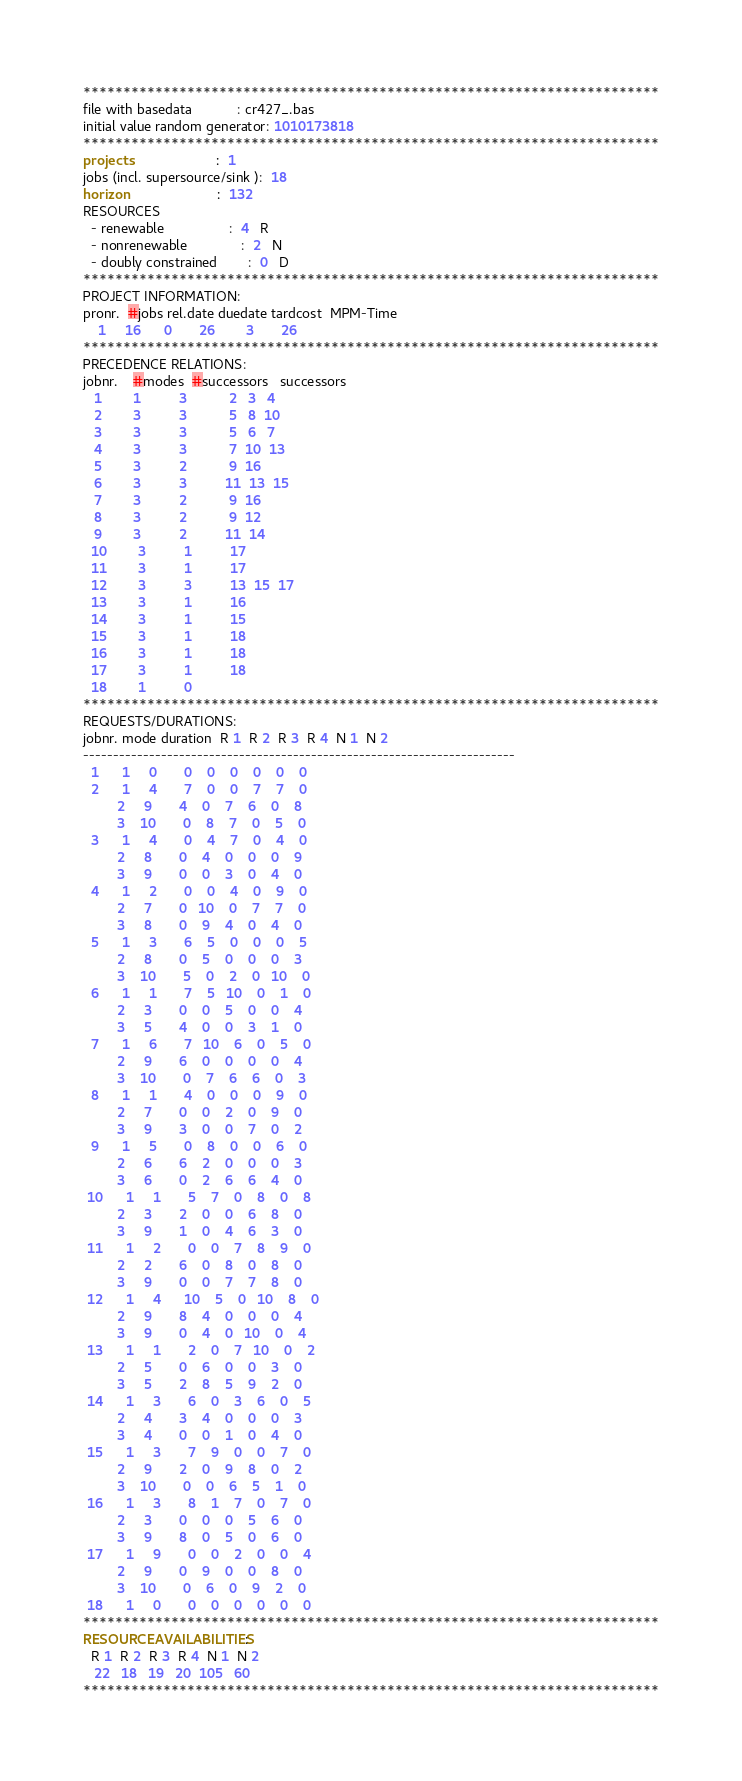<code> <loc_0><loc_0><loc_500><loc_500><_ObjectiveC_>************************************************************************
file with basedata            : cr427_.bas
initial value random generator: 1010173818
************************************************************************
projects                      :  1
jobs (incl. supersource/sink ):  18
horizon                       :  132
RESOURCES
  - renewable                 :  4   R
  - nonrenewable              :  2   N
  - doubly constrained        :  0   D
************************************************************************
PROJECT INFORMATION:
pronr.  #jobs rel.date duedate tardcost  MPM-Time
    1     16      0       26        3       26
************************************************************************
PRECEDENCE RELATIONS:
jobnr.    #modes  #successors   successors
   1        1          3           2   3   4
   2        3          3           5   8  10
   3        3          3           5   6   7
   4        3          3           7  10  13
   5        3          2           9  16
   6        3          3          11  13  15
   7        3          2           9  16
   8        3          2           9  12
   9        3          2          11  14
  10        3          1          17
  11        3          1          17
  12        3          3          13  15  17
  13        3          1          16
  14        3          1          15
  15        3          1          18
  16        3          1          18
  17        3          1          18
  18        1          0        
************************************************************************
REQUESTS/DURATIONS:
jobnr. mode duration  R 1  R 2  R 3  R 4  N 1  N 2
------------------------------------------------------------------------
  1      1     0       0    0    0    0    0    0
  2      1     4       7    0    0    7    7    0
         2     9       4    0    7    6    0    8
         3    10       0    8    7    0    5    0
  3      1     4       0    4    7    0    4    0
         2     8       0    4    0    0    0    9
         3     9       0    0    3    0    4    0
  4      1     2       0    0    4    0    9    0
         2     7       0   10    0    7    7    0
         3     8       0    9    4    0    4    0
  5      1     3       6    5    0    0    0    5
         2     8       0    5    0    0    0    3
         3    10       5    0    2    0   10    0
  6      1     1       7    5   10    0    1    0
         2     3       0    0    5    0    0    4
         3     5       4    0    0    3    1    0
  7      1     6       7   10    6    0    5    0
         2     9       6    0    0    0    0    4
         3    10       0    7    6    6    0    3
  8      1     1       4    0    0    0    9    0
         2     7       0    0    2    0    9    0
         3     9       3    0    0    7    0    2
  9      1     5       0    8    0    0    6    0
         2     6       6    2    0    0    0    3
         3     6       0    2    6    6    4    0
 10      1     1       5    7    0    8    0    8
         2     3       2    0    0    6    8    0
         3     9       1    0    4    6    3    0
 11      1     2       0    0    7    8    9    0
         2     2       6    0    8    0    8    0
         3     9       0    0    7    7    8    0
 12      1     4      10    5    0   10    8    0
         2     9       8    4    0    0    0    4
         3     9       0    4    0   10    0    4
 13      1     1       2    0    7   10    0    2
         2     5       0    6    0    0    3    0
         3     5       2    8    5    9    2    0
 14      1     3       6    0    3    6    0    5
         2     4       3    4    0    0    0    3
         3     4       0    0    1    0    4    0
 15      1     3       7    9    0    0    7    0
         2     9       2    0    9    8    0    2
         3    10       0    0    6    5    1    0
 16      1     3       8    1    7    0    7    0
         2     3       0    0    0    5    6    0
         3     9       8    0    5    0    6    0
 17      1     9       0    0    2    0    0    4
         2     9       0    9    0    0    8    0
         3    10       0    6    0    9    2    0
 18      1     0       0    0    0    0    0    0
************************************************************************
RESOURCEAVAILABILITIES:
  R 1  R 2  R 3  R 4  N 1  N 2
   22   18   19   20  105   60
************************************************************************
</code> 